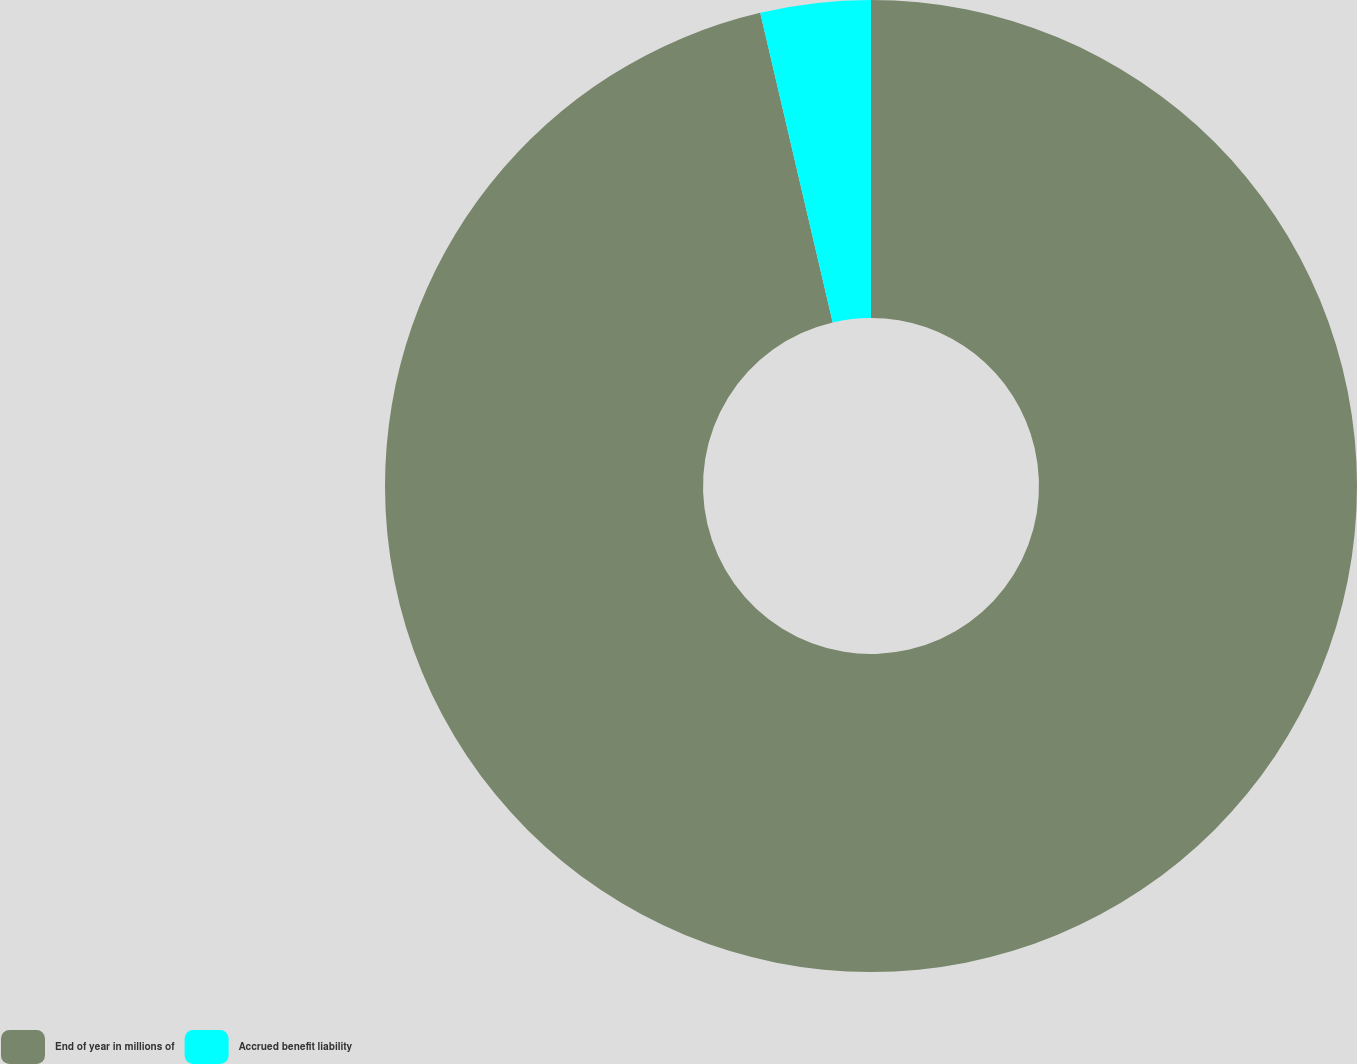Convert chart to OTSL. <chart><loc_0><loc_0><loc_500><loc_500><pie_chart><fcel>End of year in millions of<fcel>Accrued benefit liability<nl><fcel>96.34%<fcel>3.66%<nl></chart> 